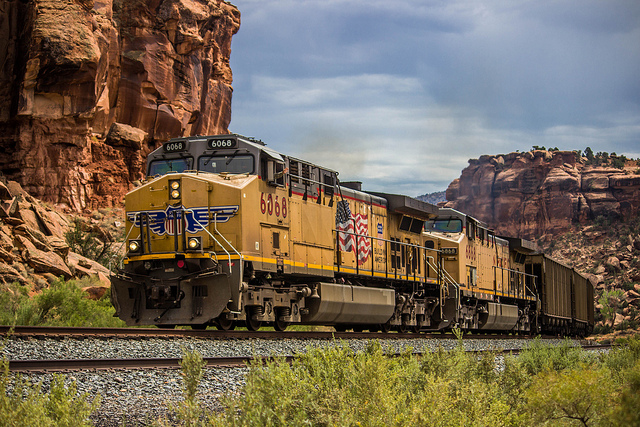Please identify all text content in this image. 6068 6068 6068 